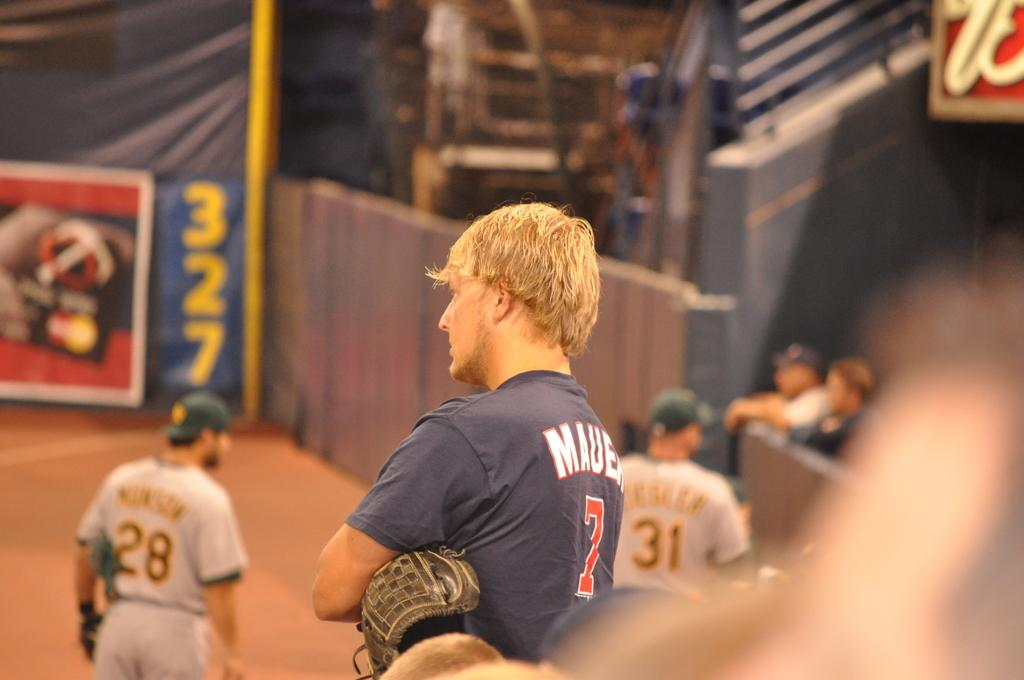<image>
Give a short and clear explanation of the subsequent image. A man wearing a blue number 7 T-shirt folds his arms and looks on. 